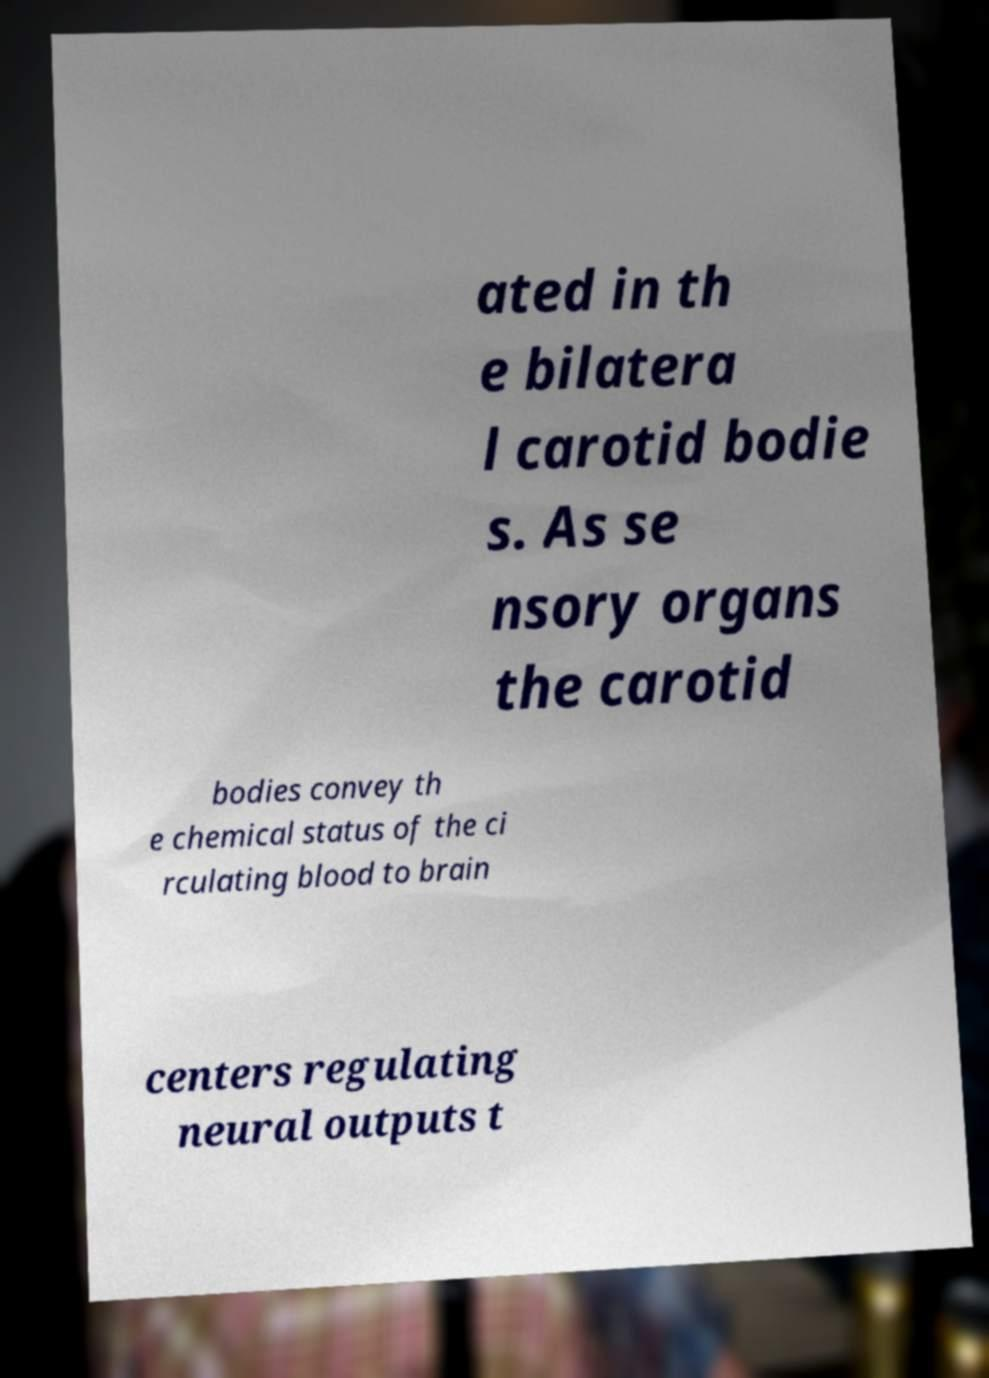Please read and relay the text visible in this image. What does it say? ated in th e bilatera l carotid bodie s. As se nsory organs the carotid bodies convey th e chemical status of the ci rculating blood to brain centers regulating neural outputs t 